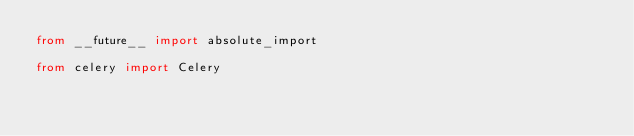Convert code to text. <code><loc_0><loc_0><loc_500><loc_500><_Python_>from __future__ import absolute_import

from celery import Celery</code> 